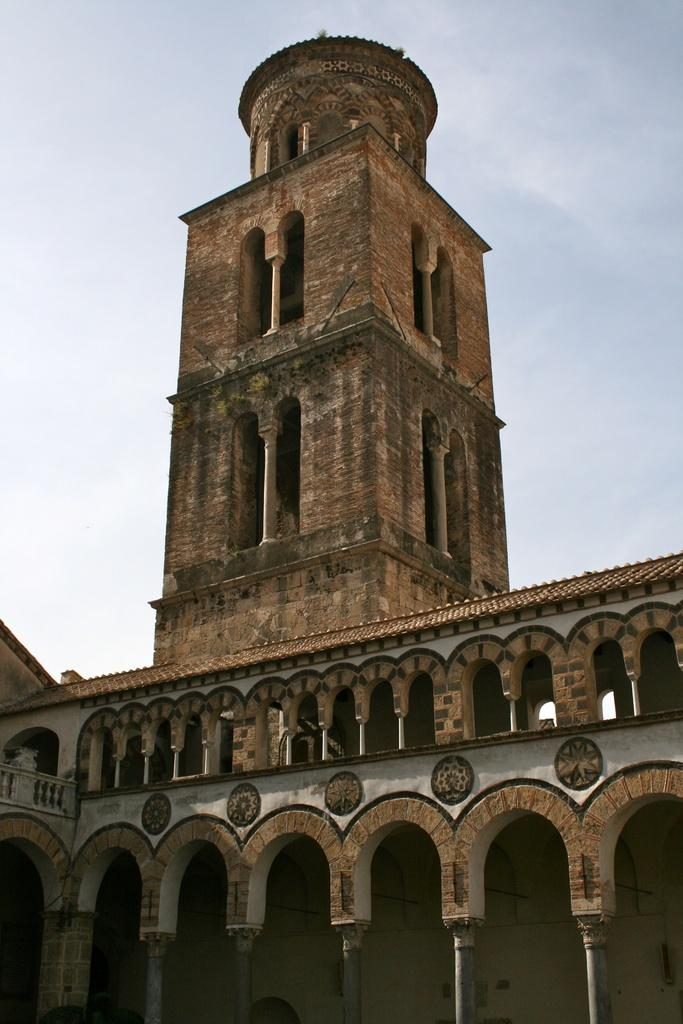What type of structure is the main subject of the image? There is a castle in the image. What is the color of the castle? The castle is brown in color. What can be seen in the background of the image? The blue sky is visible in the background of the image. What type of cars are parked near the castle in the image? There are no cars present in the image; it only features a brown castle with a blue sky in the background. 